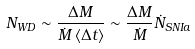Convert formula to latex. <formula><loc_0><loc_0><loc_500><loc_500>N _ { W D } \sim \frac { \Delta M } { \dot { M } \left < \Delta t \right > } \sim \frac { \Delta M } { \dot { M } } \dot { N } _ { S N I a }</formula> 